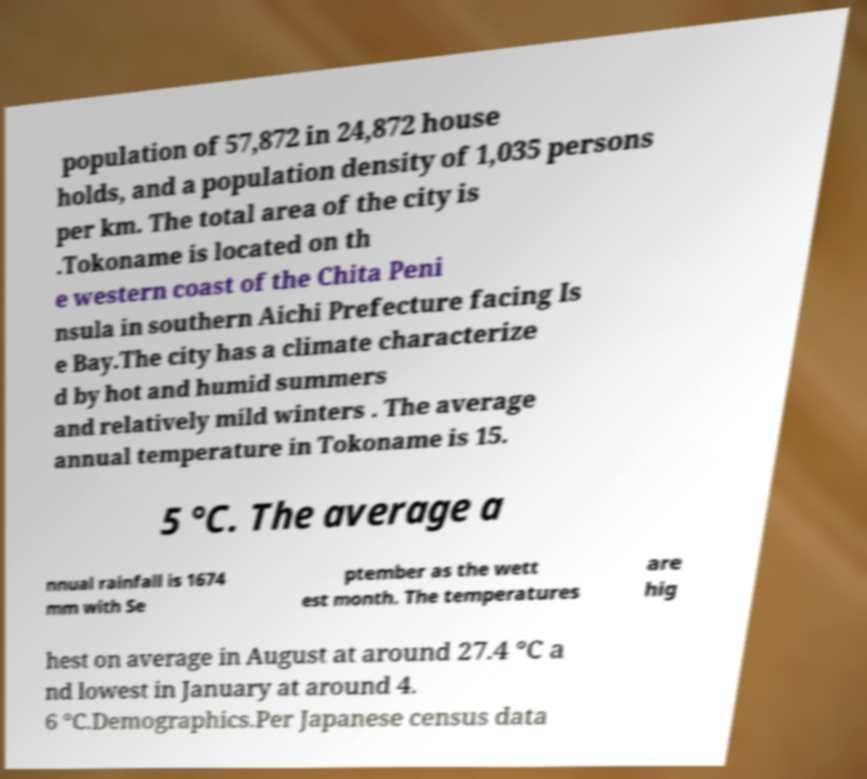For documentation purposes, I need the text within this image transcribed. Could you provide that? population of 57,872 in 24,872 house holds, and a population density of 1,035 persons per km. The total area of the city is .Tokoname is located on th e western coast of the Chita Peni nsula in southern Aichi Prefecture facing Is e Bay.The city has a climate characterize d by hot and humid summers and relatively mild winters . The average annual temperature in Tokoname is 15. 5 °C. The average a nnual rainfall is 1674 mm with Se ptember as the wett est month. The temperatures are hig hest on average in August at around 27.4 °C a nd lowest in January at around 4. 6 °C.Demographics.Per Japanese census data 